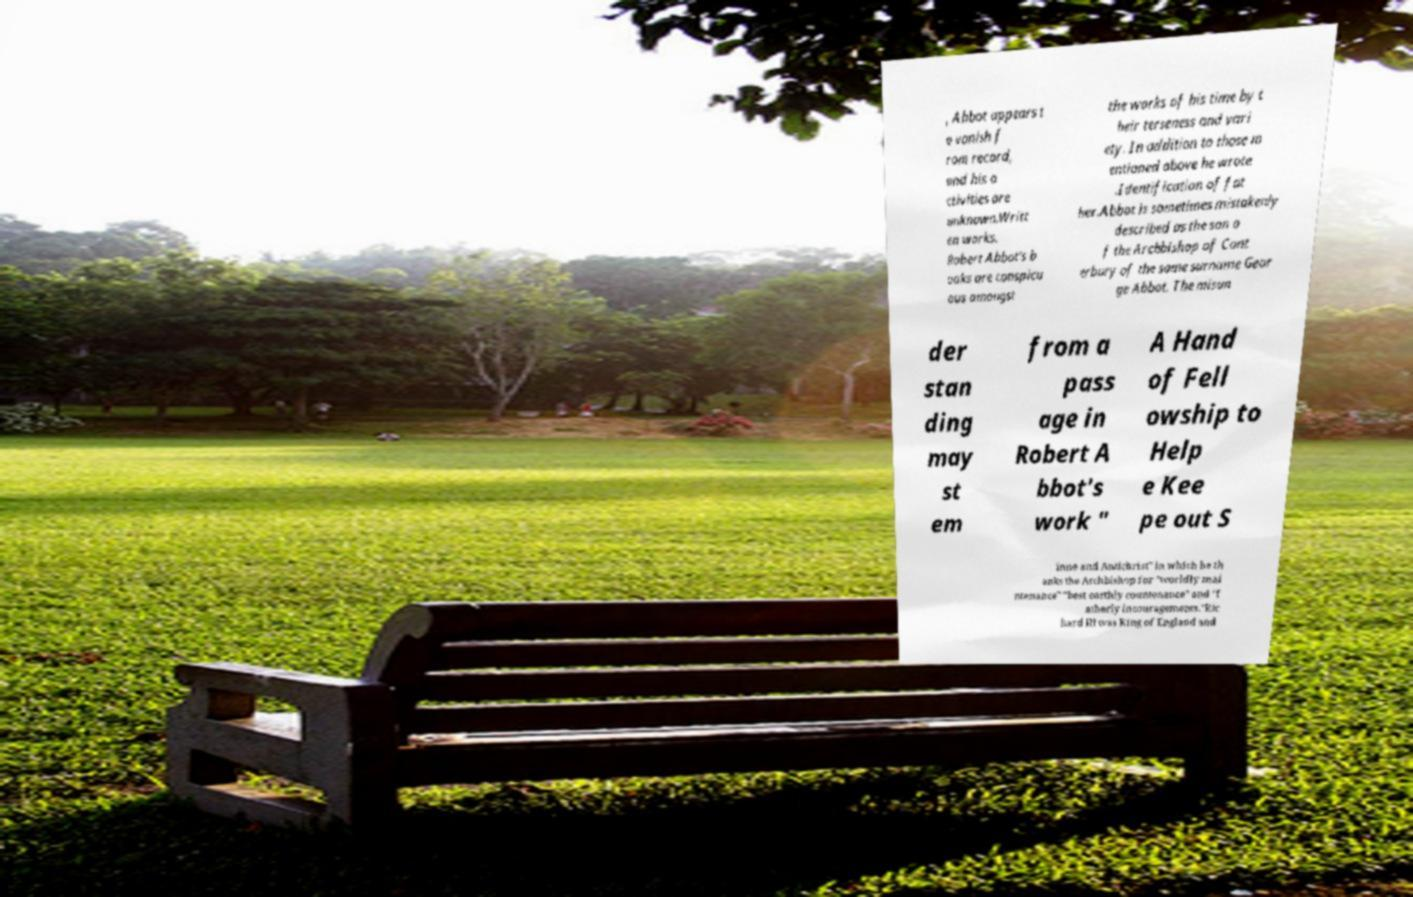Could you assist in decoding the text presented in this image and type it out clearly? , Abbot appears t o vanish f rom record, and his a ctivities are unknown.Writt en works. Robert Abbot's b ooks are conspicu ous amongst the works of his time by t heir terseness and vari ety. In addition to those m entioned above he wrote .Identification of fat her.Abbot is sometimes mistakenly described as the son o f the Archbishop of Cant erbury of the same surname Geor ge Abbot. The misun der stan ding may st em from a pass age in Robert A bbot's work " A Hand of Fell owship to Help e Kee pe out S inne and Antichrist" in which he th anks the Archbishop for "worldly mai ntenance" "best earthly countenance" and "f atherly incouragements."Ric hard III was King of England and 